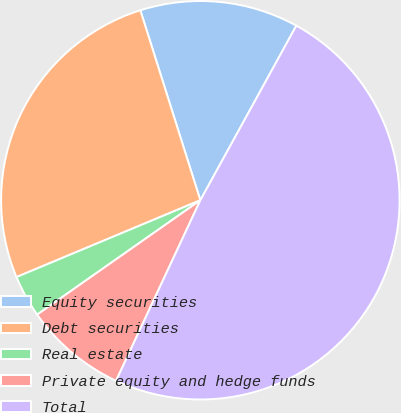Convert chart to OTSL. <chart><loc_0><loc_0><loc_500><loc_500><pie_chart><fcel>Equity securities<fcel>Debt securities<fcel>Real estate<fcel>Private equity and hedge funds<fcel>Total<nl><fcel>12.87%<fcel>26.43%<fcel>3.43%<fcel>8.32%<fcel>48.95%<nl></chart> 